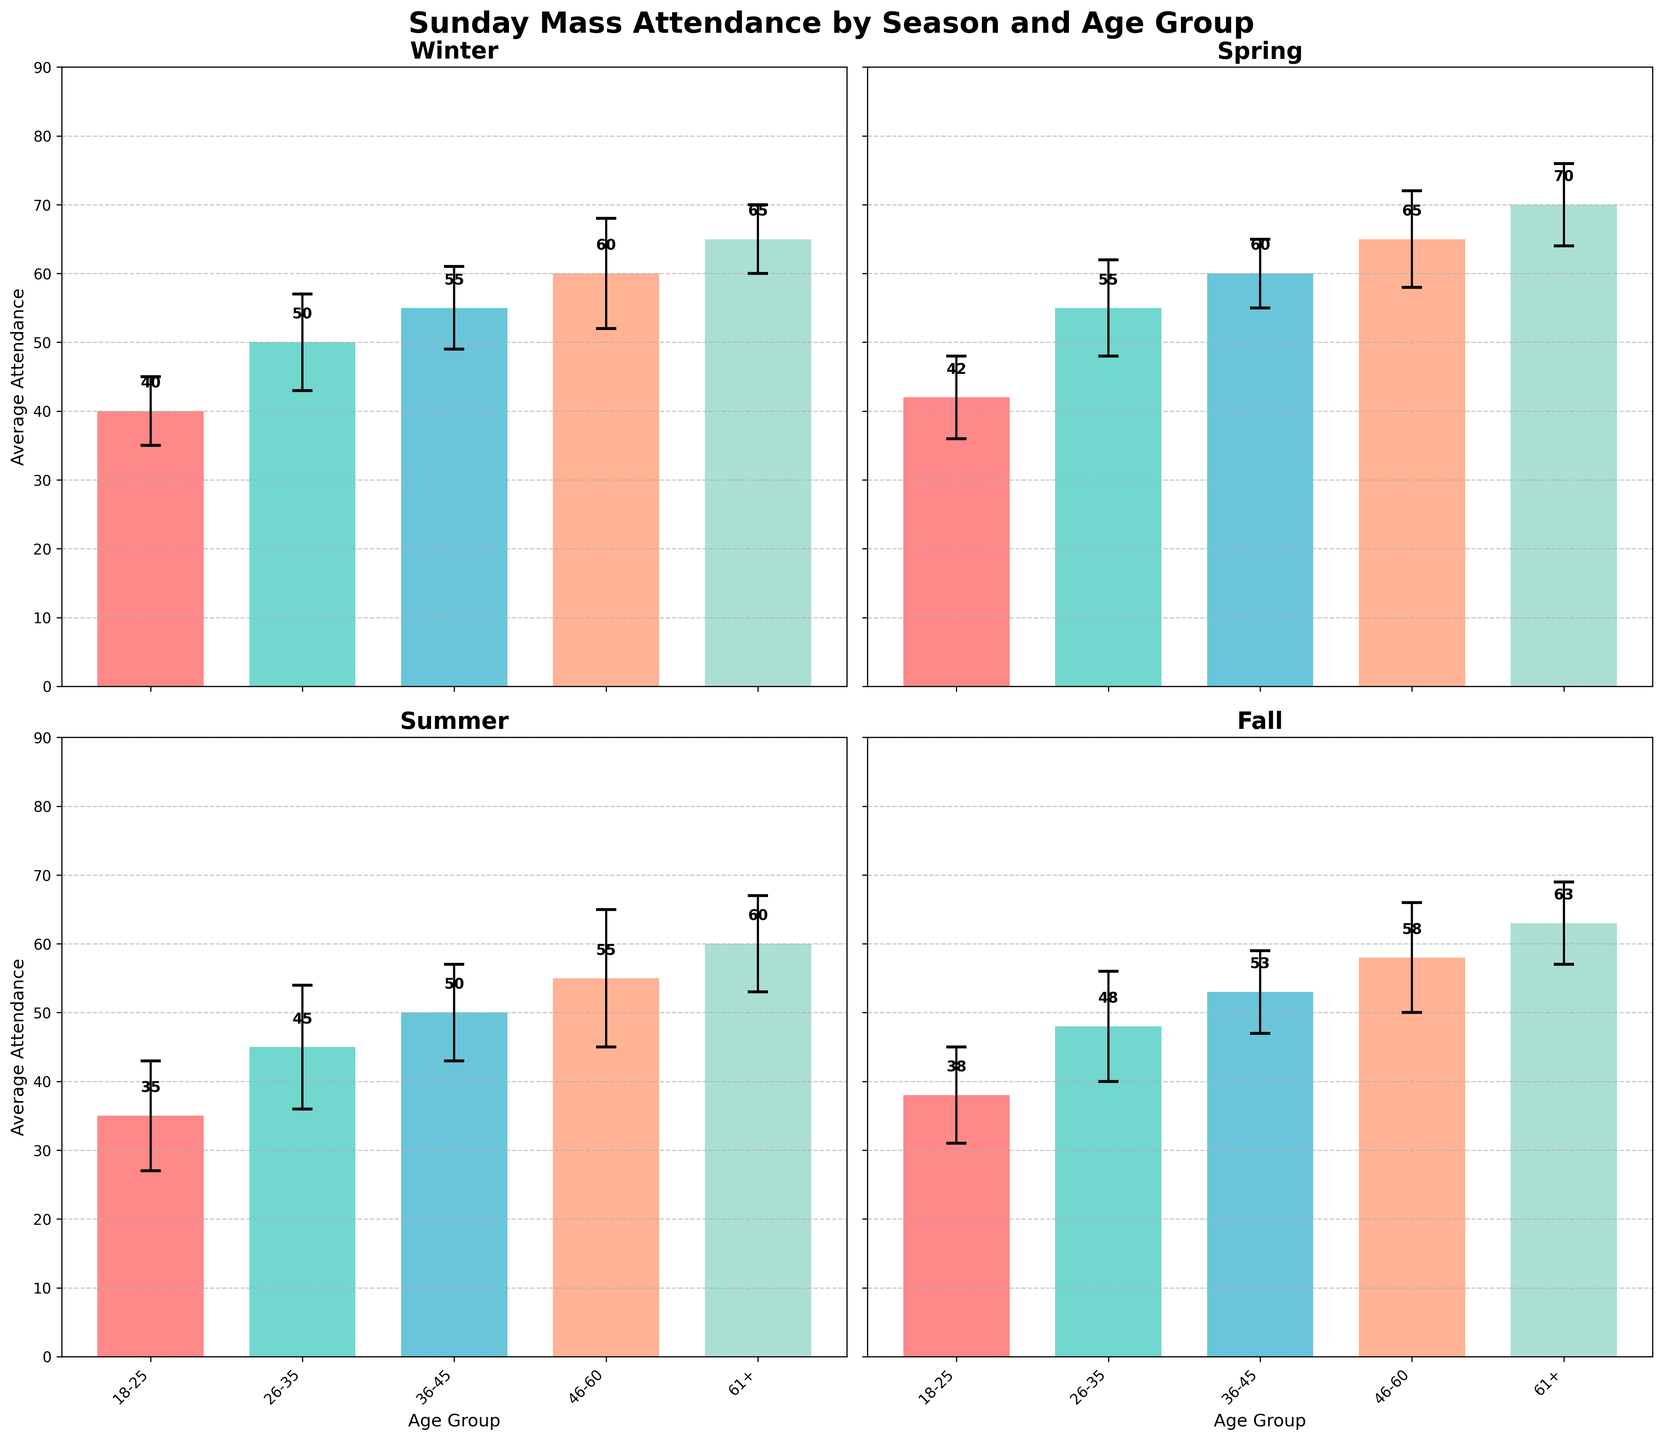What is the title of the figure? The title is located at the top of the figure, displayed in large, bold text. It reads "Sunday Mass Attendance by Season and Age Group."
Answer: Sunday Mass Attendance by Season and Age Group What is the average attendance for the age group 46-60 in Spring? Look for the Spring subplot and find the bar corresponding to the age group 46-60. The height of the bar denotes the average attendance, which is labeled above each bar.
Answer: 65 Which season shows the highest average attendance for the age group 61+? Compare the heights of the bars corresponding to the age group 61+ across all four subplots. The subplot with the tallest bar represents the highest average attendance.
Answer: Spring What is the difference in average attendance between Winter and Summer for the age group 18-25? Find the bars for the 18-25 age group in both the Winter and Summer subplots. Subtract the height of the Summer bar from the Winter bar.
Answer: 5 In which season does the age group 26-35 have the most variation in attendance? Check the error bars (lines showing standard deviation) for the age group 26-35 in all seasons. The season with the longest error bar has the most variation.
Answer: Summer What is the combined average attendance for the age group 36-45 across all seasons? Sum the heights of the bars for the age group 36-45 in each season.
Answer: 218 Which age group has the lowest attendance in Summer and what is the value? In the Summer subplot, identify the age group with the shortest bar and note the height of that bar.
Answer: 18-25, 35 How does the attendance for the age group 46-60 vary between Winter and Fall? Compare the heights of the bars for the age group 46-60 in the Winter and Fall subplots. Note whether one is greater than, less than, or equal to the other.
Answer: Winter has higher attendance than Fall What is the range of average attendance for the age group 61+ across all seasons? Determine the highest and lowest average attendance for the age group 61+ in any season. Subtract the lowest value from the highest value.
Answer: 70 - 60 = 10 Which season has the most consistent attendance across all age groups? Evaluate the lengths of the error bars for all age groups in each season. The season with the shortest error bars overall is the most consistent.
Answer: Winter 